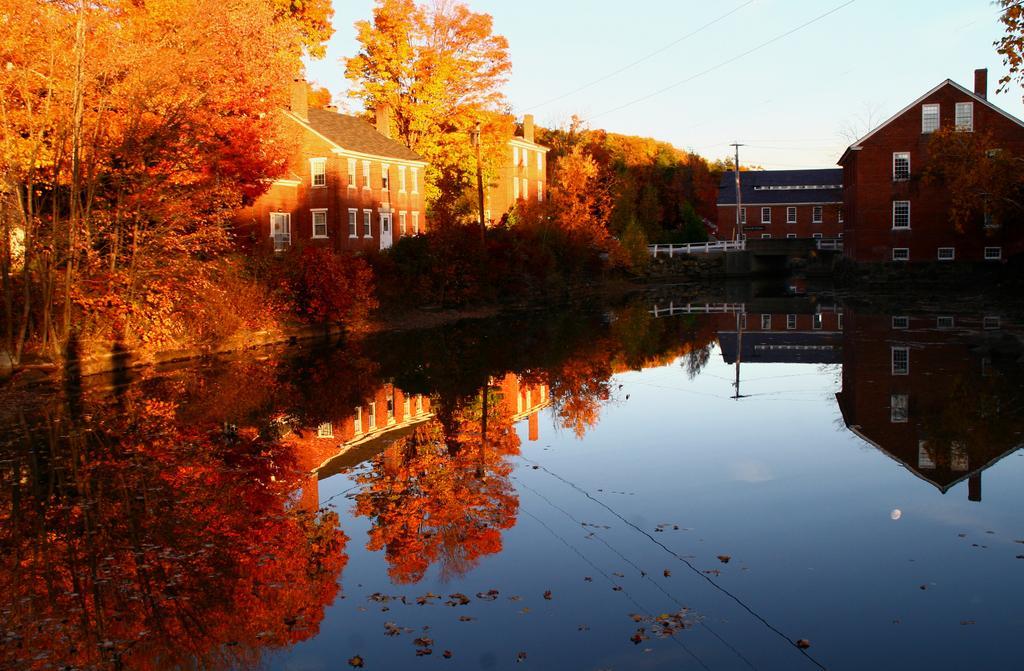Please provide a concise description of this image. In front of the image there is water. In the background of the image there are buildings, trees. There is a metal fence. There is a current pole. At the top of the image there is sky. 